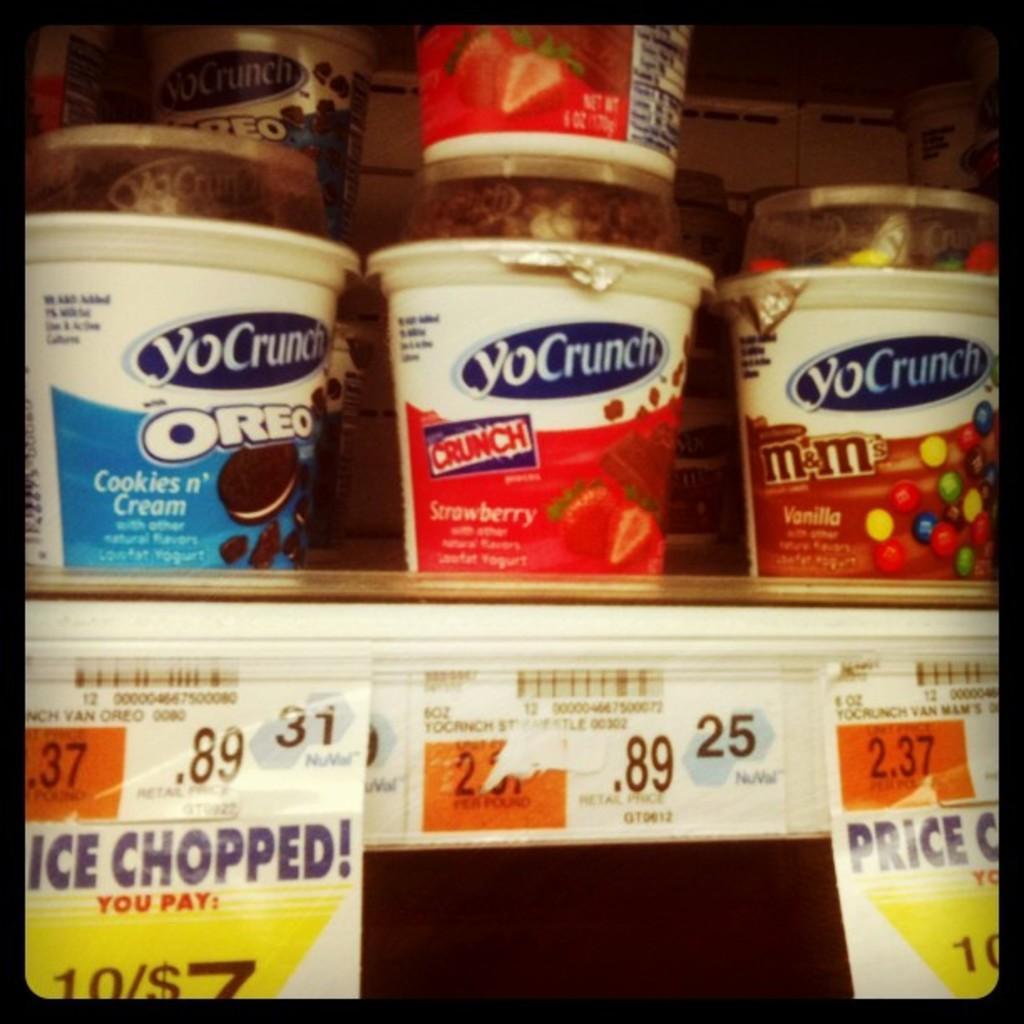Please provide a concise description of this image. In this image, we can see some cups. There are labels at the bottom of the image. 